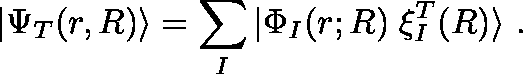Convert formula to latex. <formula><loc_0><loc_0><loc_500><loc_500>| \Psi _ { T } ( r , R ) \rangle = \sum _ { I } | \Phi _ { I } ( r ; R ) \, \xi _ { I } ^ { T } ( R ) \rangle .</formula> 